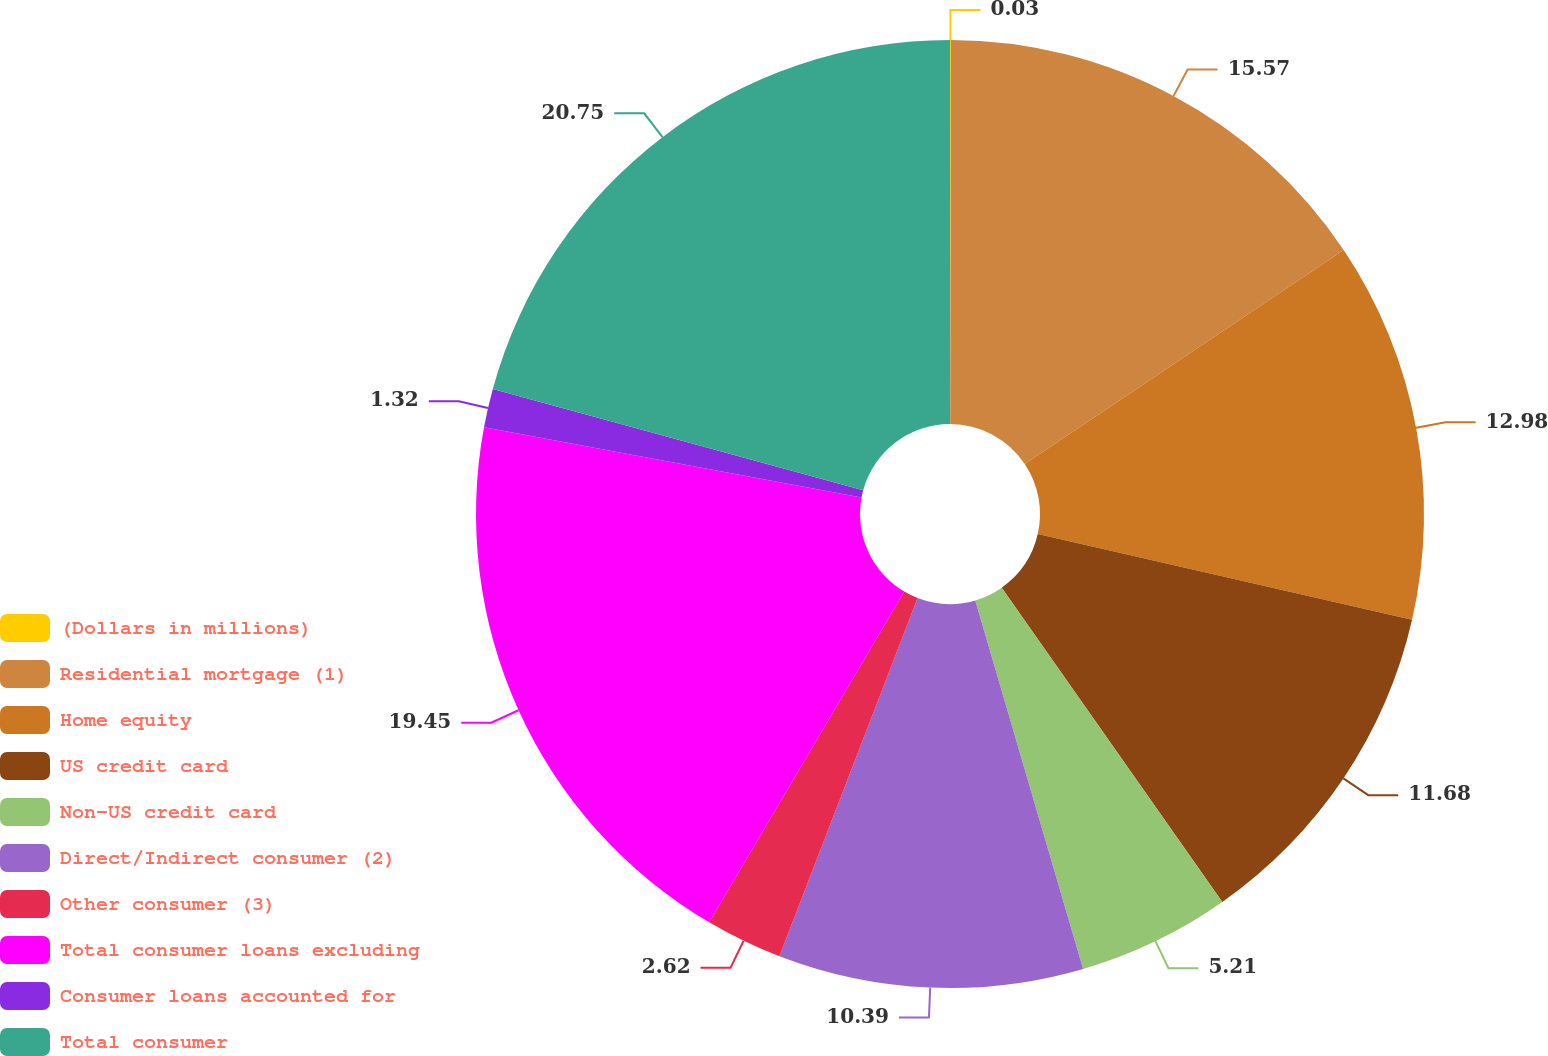<chart> <loc_0><loc_0><loc_500><loc_500><pie_chart><fcel>(Dollars in millions)<fcel>Residential mortgage (1)<fcel>Home equity<fcel>US credit card<fcel>Non-US credit card<fcel>Direct/Indirect consumer (2)<fcel>Other consumer (3)<fcel>Total consumer loans excluding<fcel>Consumer loans accounted for<fcel>Total consumer<nl><fcel>0.03%<fcel>15.57%<fcel>12.98%<fcel>11.68%<fcel>5.21%<fcel>10.39%<fcel>2.62%<fcel>19.45%<fcel>1.32%<fcel>20.75%<nl></chart> 